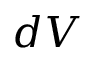<formula> <loc_0><loc_0><loc_500><loc_500>d V</formula> 